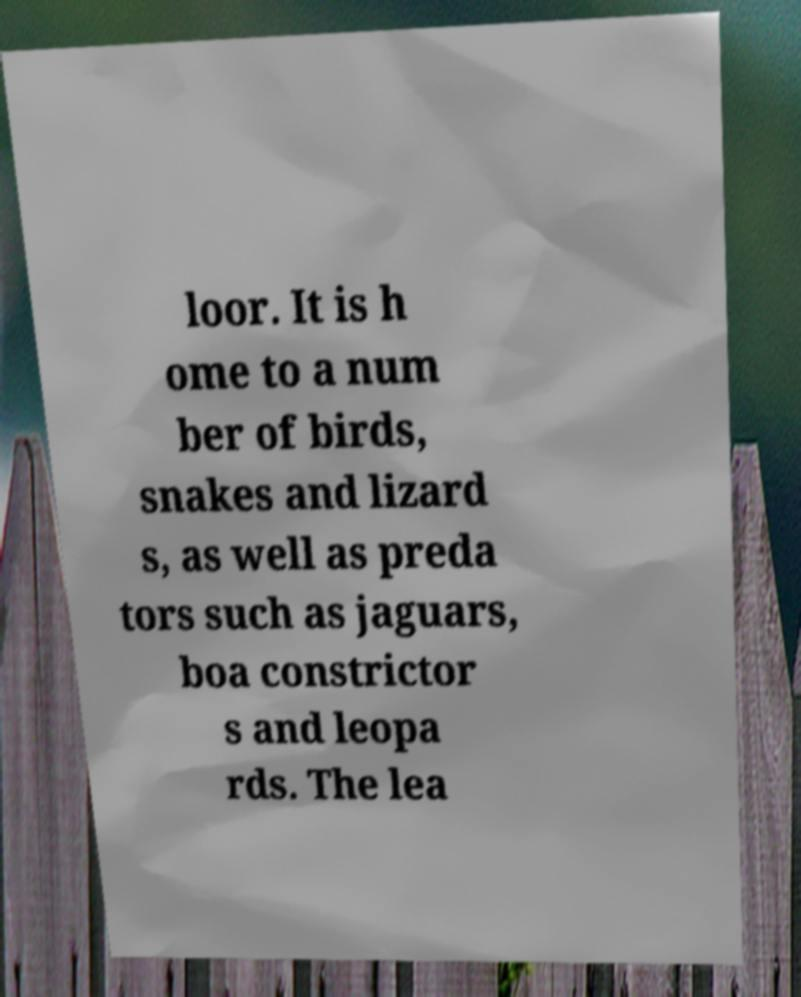Please identify and transcribe the text found in this image. loor. It is h ome to a num ber of birds, snakes and lizard s, as well as preda tors such as jaguars, boa constrictor s and leopa rds. The lea 